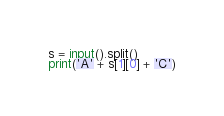<code> <loc_0><loc_0><loc_500><loc_500><_Python_>s = input().split()
print('A' + s[1][0] + 'C')
</code> 